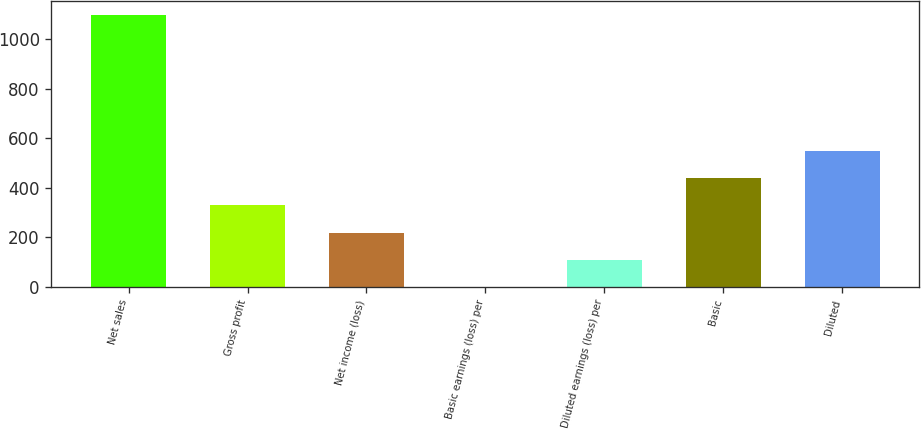Convert chart to OTSL. <chart><loc_0><loc_0><loc_500><loc_500><bar_chart><fcel>Net sales<fcel>Gross profit<fcel>Net income (loss)<fcel>Basic earnings (loss) per<fcel>Diluted earnings (loss) per<fcel>Basic<fcel>Diluted<nl><fcel>1100<fcel>330.08<fcel>220.09<fcel>0.11<fcel>110.1<fcel>440.07<fcel>550.06<nl></chart> 